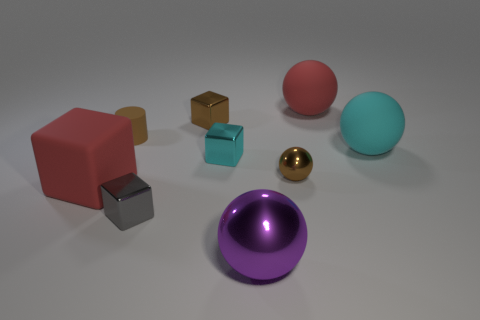Subtract 1 cubes. How many cubes are left? 3 Add 1 large metallic objects. How many objects exist? 10 Subtract all cubes. How many objects are left? 5 Subtract all big yellow matte cylinders. Subtract all large red rubber spheres. How many objects are left? 8 Add 2 small spheres. How many small spheres are left? 3 Add 4 purple things. How many purple things exist? 5 Subtract 1 red cubes. How many objects are left? 8 